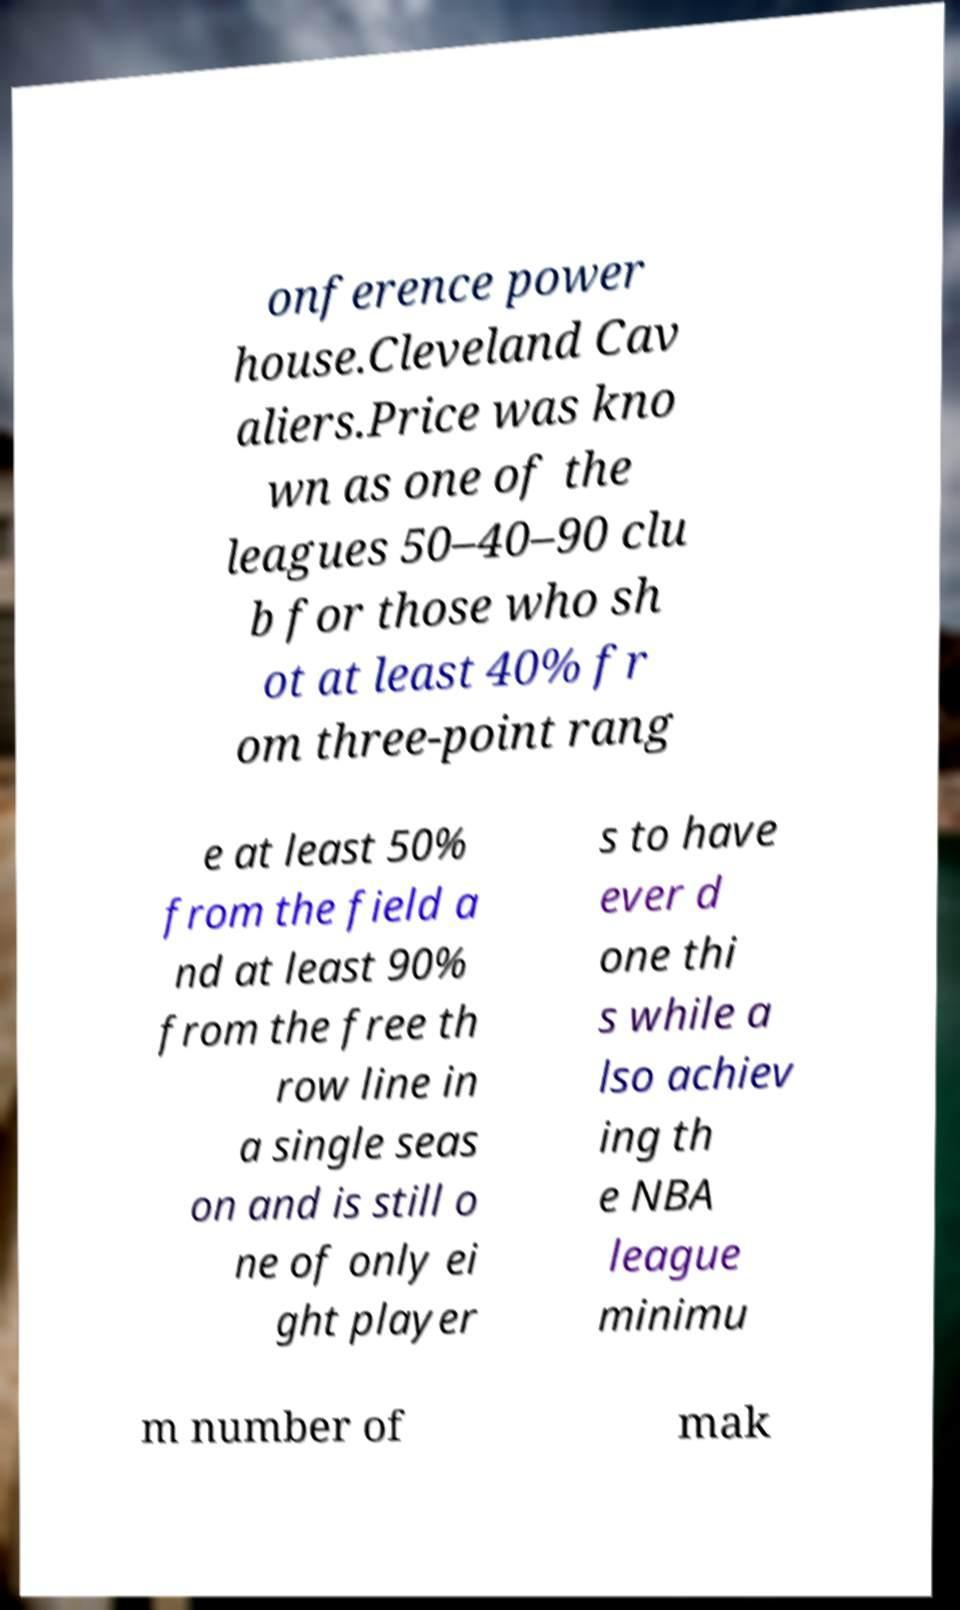I need the written content from this picture converted into text. Can you do that? onference power house.Cleveland Cav aliers.Price was kno wn as one of the leagues 50–40–90 clu b for those who sh ot at least 40% fr om three-point rang e at least 50% from the field a nd at least 90% from the free th row line in a single seas on and is still o ne of only ei ght player s to have ever d one thi s while a lso achiev ing th e NBA league minimu m number of mak 